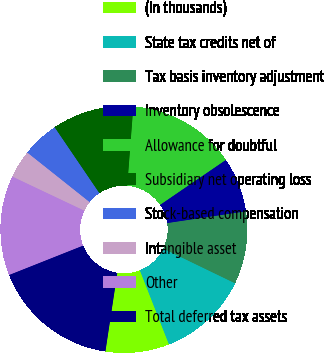Convert chart to OTSL. <chart><loc_0><loc_0><loc_500><loc_500><pie_chart><fcel>(In thousands)<fcel>State tax credits net of<fcel>Tax basis inventory adjustment<fcel>Inventory obsolescence<fcel>Allowance for doubtful<fcel>Subsidiary net operating loss<fcel>Stock-based compensation<fcel>Intangible asset<fcel>Other<fcel>Total deferred tax assets<nl><fcel>8.35%<fcel>11.88%<fcel>9.53%<fcel>7.18%<fcel>14.24%<fcel>10.71%<fcel>4.82%<fcel>3.65%<fcel>13.06%<fcel>16.59%<nl></chart> 